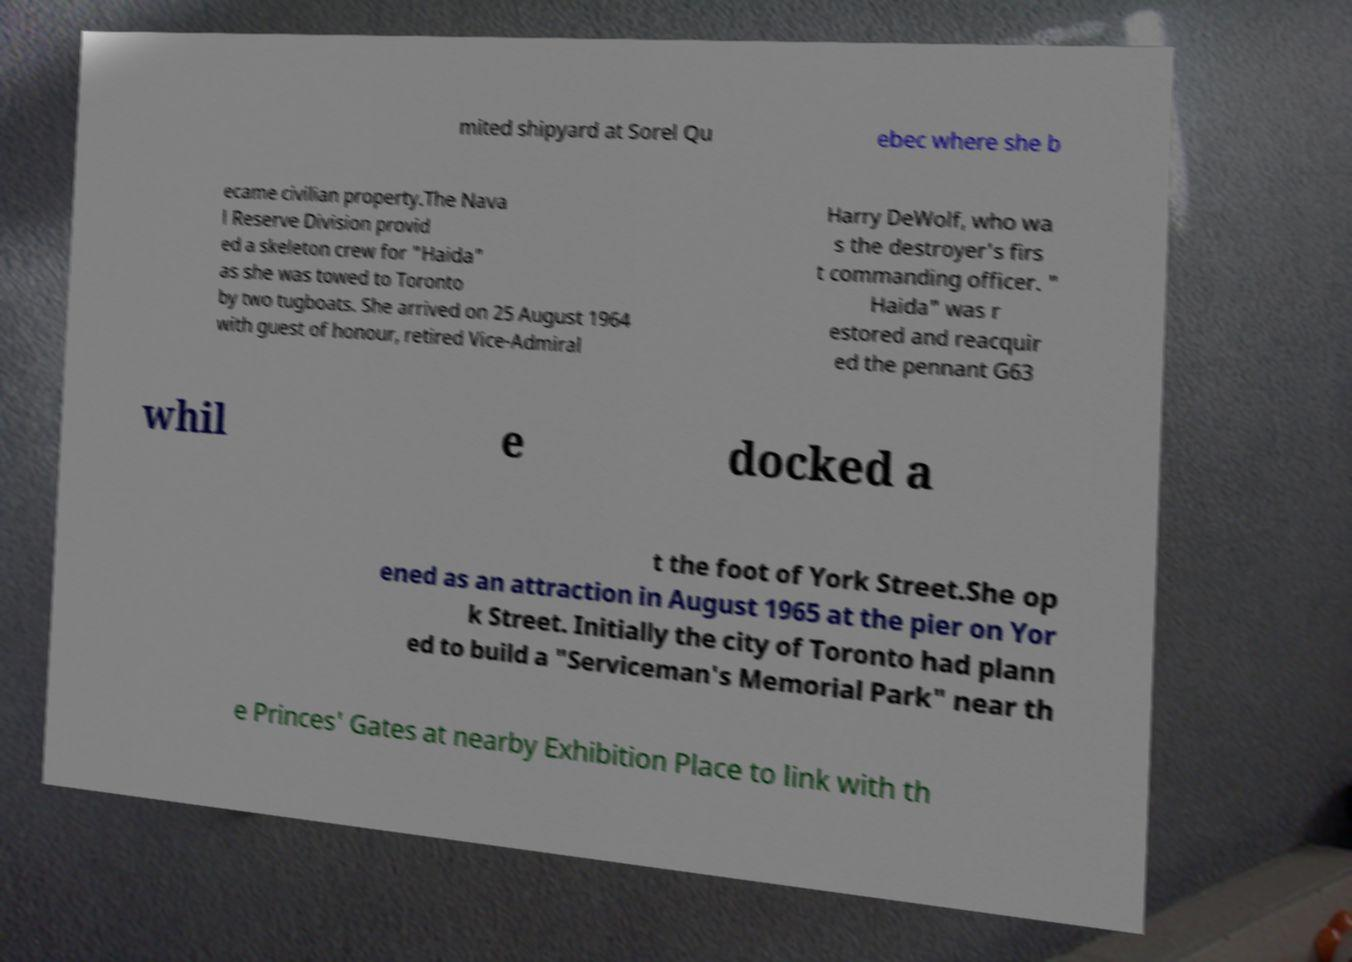Could you assist in decoding the text presented in this image and type it out clearly? mited shipyard at Sorel Qu ebec where she b ecame civilian property.The Nava l Reserve Division provid ed a skeleton crew for "Haida" as she was towed to Toronto by two tugboats. She arrived on 25 August 1964 with guest of honour, retired Vice-Admiral Harry DeWolf, who wa s the destroyer's firs t commanding officer. " Haida" was r estored and reacquir ed the pennant G63 whil e docked a t the foot of York Street.She op ened as an attraction in August 1965 at the pier on Yor k Street. Initially the city of Toronto had plann ed to build a "Serviceman's Memorial Park" near th e Princes' Gates at nearby Exhibition Place to link with th 